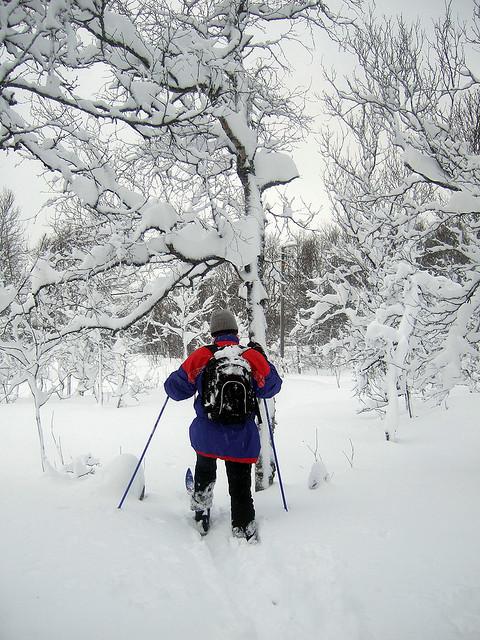How many colors of the French flag are missing from this photo?
Write a very short answer. 0. What is the skier wearing on their back?
Answer briefly. Backpack. How many people are there?
Answer briefly. 1. What is on the trees?
Quick response, please. Snow. 